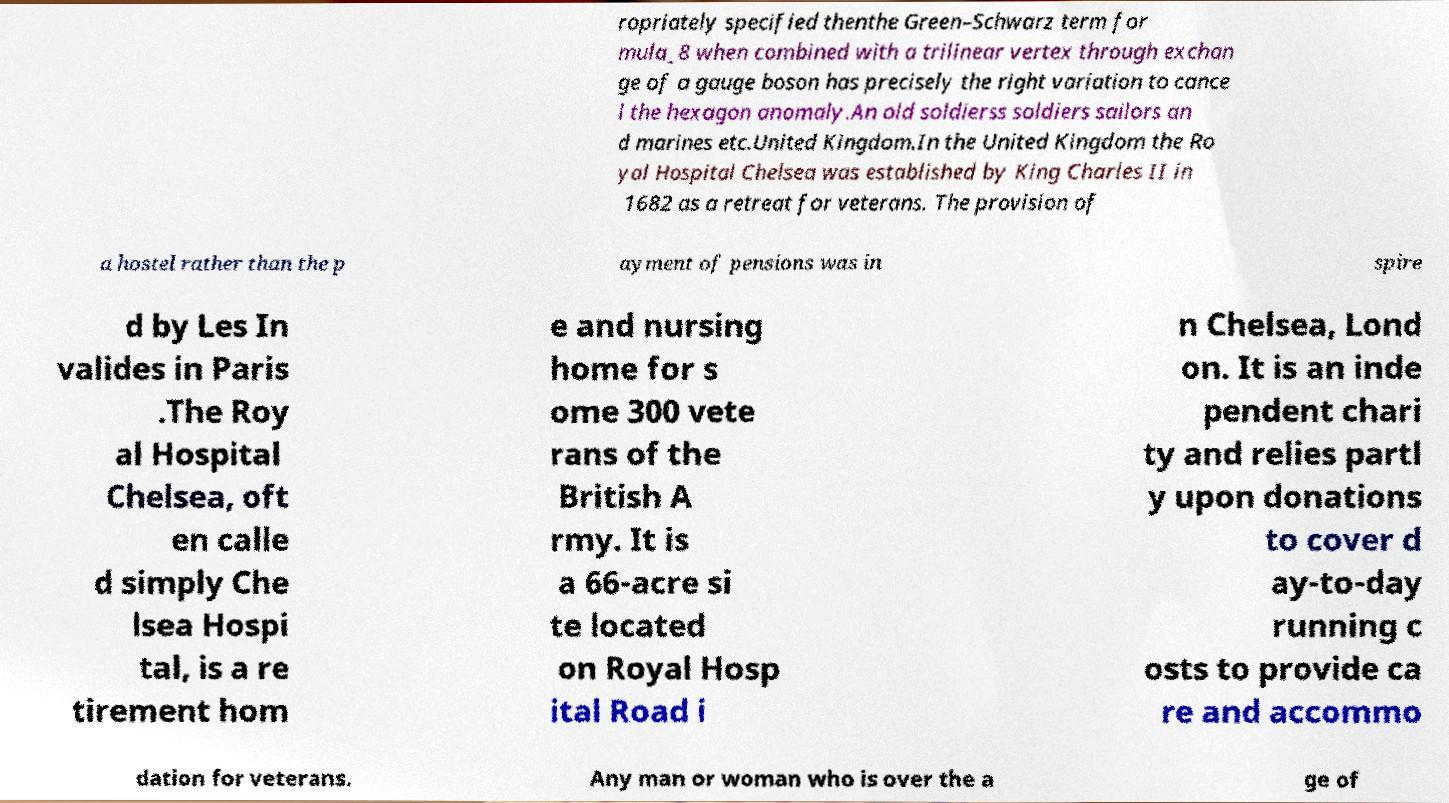I need the written content from this picture converted into text. Can you do that? ropriately specified thenthe Green–Schwarz term for mula_8 when combined with a trilinear vertex through exchan ge of a gauge boson has precisely the right variation to cance l the hexagon anomaly.An old soldierss soldiers sailors an d marines etc.United Kingdom.In the United Kingdom the Ro yal Hospital Chelsea was established by King Charles II in 1682 as a retreat for veterans. The provision of a hostel rather than the p ayment of pensions was in spire d by Les In valides in Paris .The Roy al Hospital Chelsea, oft en calle d simply Che lsea Hospi tal, is a re tirement hom e and nursing home for s ome 300 vete rans of the British A rmy. It is a 66-acre si te located on Royal Hosp ital Road i n Chelsea, Lond on. It is an inde pendent chari ty and relies partl y upon donations to cover d ay-to-day running c osts to provide ca re and accommo dation for veterans. Any man or woman who is over the a ge of 